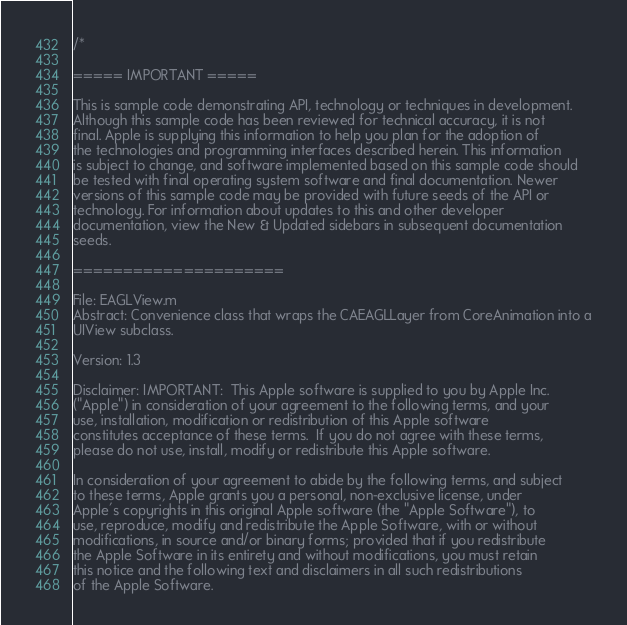<code> <loc_0><loc_0><loc_500><loc_500><_ObjectiveC_>/*

===== IMPORTANT =====

This is sample code demonstrating API, technology or techniques in development.
Although this sample code has been reviewed for technical accuracy, it is not
final. Apple is supplying this information to help you plan for the adoption of
the technologies and programming interfaces described herein. This information
is subject to change, and software implemented based on this sample code should
be tested with final operating system software and final documentation. Newer
versions of this sample code may be provided with future seeds of the API or
technology. For information about updates to this and other developer
documentation, view the New & Updated sidebars in subsequent documentation
seeds.

=====================

File: EAGLView.m
Abstract: Convenience class that wraps the CAEAGLLayer from CoreAnimation into a
UIView subclass.

Version: 1.3

Disclaimer: IMPORTANT:  This Apple software is supplied to you by Apple Inc.
("Apple") in consideration of your agreement to the following terms, and your
use, installation, modification or redistribution of this Apple software
constitutes acceptance of these terms.  If you do not agree with these terms,
please do not use, install, modify or redistribute this Apple software.

In consideration of your agreement to abide by the following terms, and subject
to these terms, Apple grants you a personal, non-exclusive license, under
Apple's copyrights in this original Apple software (the "Apple Software"), to
use, reproduce, modify and redistribute the Apple Software, with or without
modifications, in source and/or binary forms; provided that if you redistribute
the Apple Software in its entirety and without modifications, you must retain
this notice and the following text and disclaimers in all such redistributions
of the Apple Software.</code> 